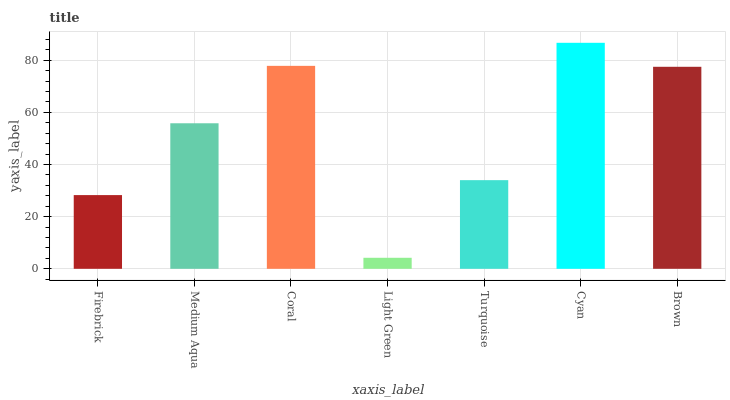Is Medium Aqua the minimum?
Answer yes or no. No. Is Medium Aqua the maximum?
Answer yes or no. No. Is Medium Aqua greater than Firebrick?
Answer yes or no. Yes. Is Firebrick less than Medium Aqua?
Answer yes or no. Yes. Is Firebrick greater than Medium Aqua?
Answer yes or no. No. Is Medium Aqua less than Firebrick?
Answer yes or no. No. Is Medium Aqua the high median?
Answer yes or no. Yes. Is Medium Aqua the low median?
Answer yes or no. Yes. Is Cyan the high median?
Answer yes or no. No. Is Firebrick the low median?
Answer yes or no. No. 